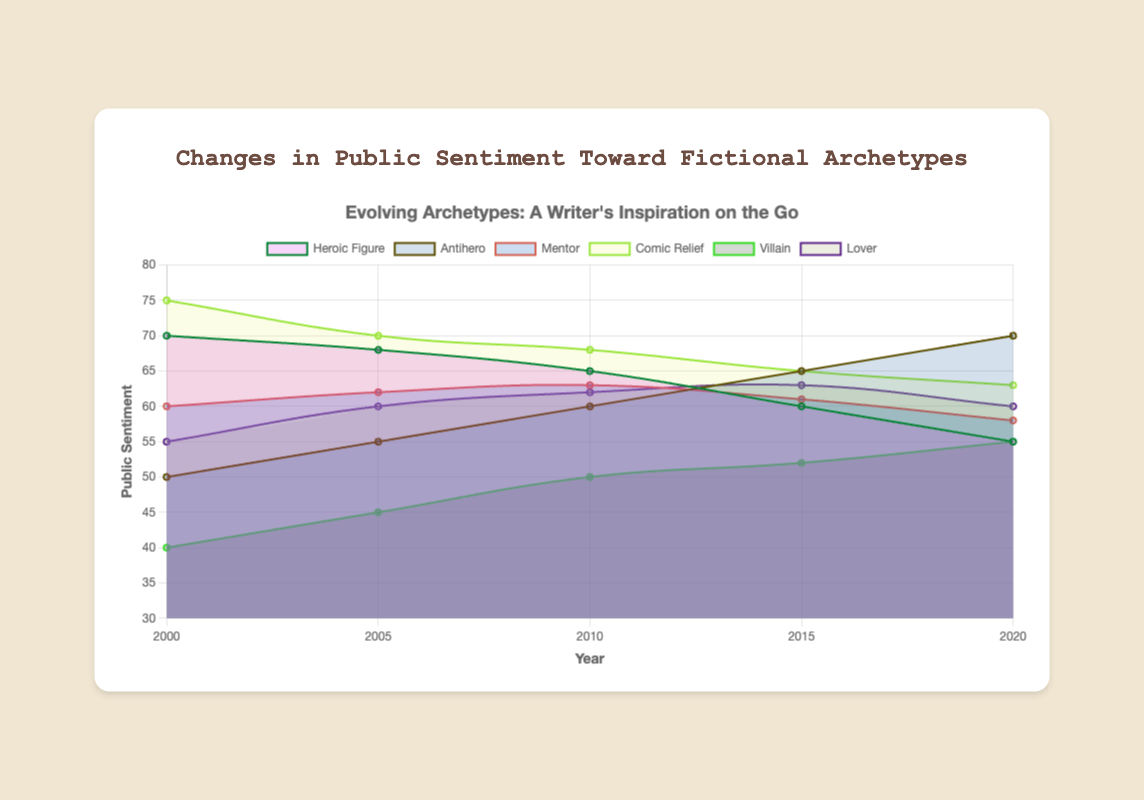What is the overall trend in public sentiment toward the "Heroic Figure" from 2000 to 2020? The sentiment towards the "Heroic Figure" decreases over the years, starting at 70 in 2000 and dropping to 55 in 2020.
Answer: It decreases Which archetype shows an increasing trend in public sentiment from 2000 to 2020? The "Antihero" archetype shows an increasing trend, starting at 50 in 2000 and rising to 70 in 2020.
Answer: Antihero By how many points did the sentiment toward "Comic Relief" decrease between 2000 and 2020? The sentiment towards "Comic Relief" dropped from 75 in 2000 to 63 in 2020. The difference is 75 - 63.
Answer: 12 points Which two archetypes have the most similar sentiment scores in 2020? In 2020, the "Heroic Figure" and "Villain" both have a sentiment score of 55.
Answer: Heroic Figure and Villain What is the average sentiment score of the "Mentor" archetype from 2000 to 2020? The sentiment scores are 60, 62, 63, 61, and 58. Their average is (60 + 62 + 63 + 61 + 58) / 5.
Answer: 60.8 Which archetype had the lowest public sentiment score in 2000? In 2000, the "Villain" had the lowest sentiment score at 40.
Answer: Villain Did the sentiment towards the "Lover" archetype ever decrease between any two consecutive years? Yes, the sentiment score for "Lover" dropped from 63 in 2015 to 60 in 2020.
Answer: Yes What is the difference in sentiment scores between the "Heroic Figure" and "Antihero" in 2010? In 2010, the "Heroic Figure" had a score of 65, and the "Antihero" had 60. The difference is 65 - 60.
Answer: 5 points 